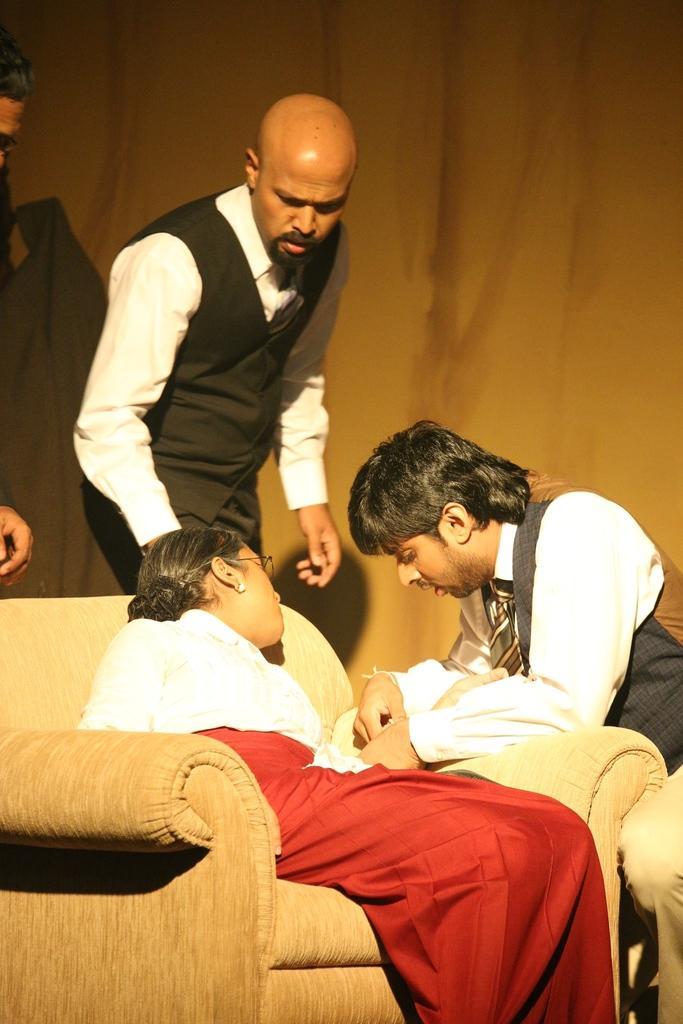How would you summarize this image in a sentence or two? In this picture I can see a woman sitting on the chair, there is a person holding her hand, there are two persons standing. 